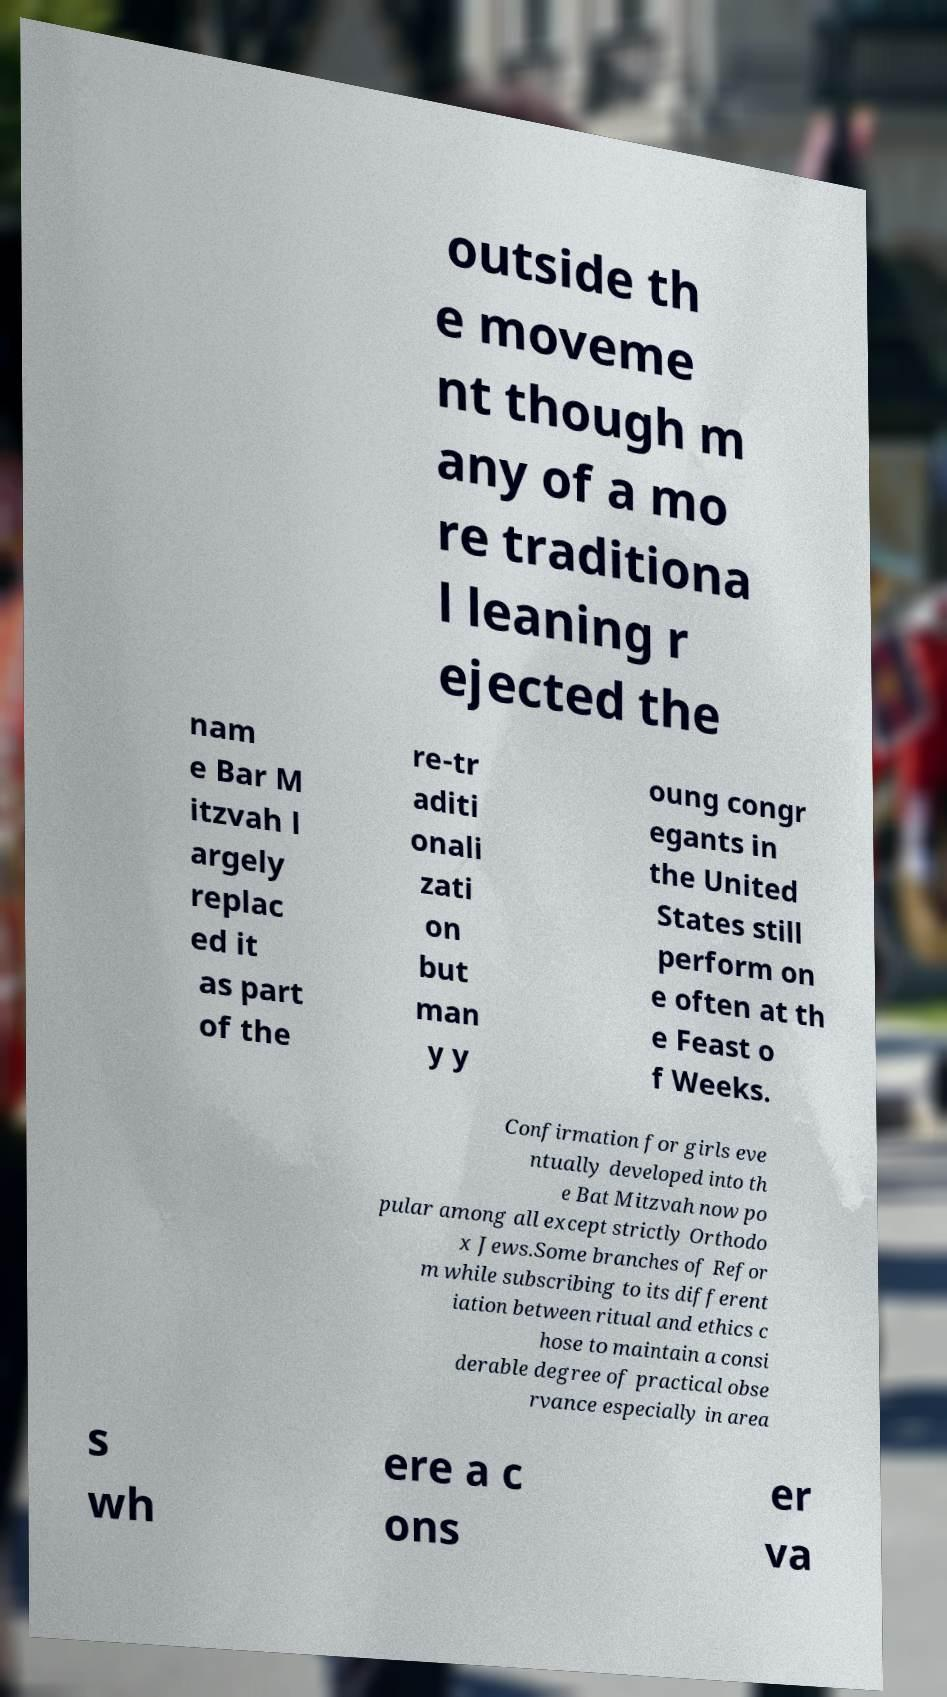I need the written content from this picture converted into text. Can you do that? outside th e moveme nt though m any of a mo re traditiona l leaning r ejected the nam e Bar M itzvah l argely replac ed it as part of the re-tr aditi onali zati on but man y y oung congr egants in the United States still perform on e often at th e Feast o f Weeks. Confirmation for girls eve ntually developed into th e Bat Mitzvah now po pular among all except strictly Orthodo x Jews.Some branches of Refor m while subscribing to its different iation between ritual and ethics c hose to maintain a consi derable degree of practical obse rvance especially in area s wh ere a c ons er va 